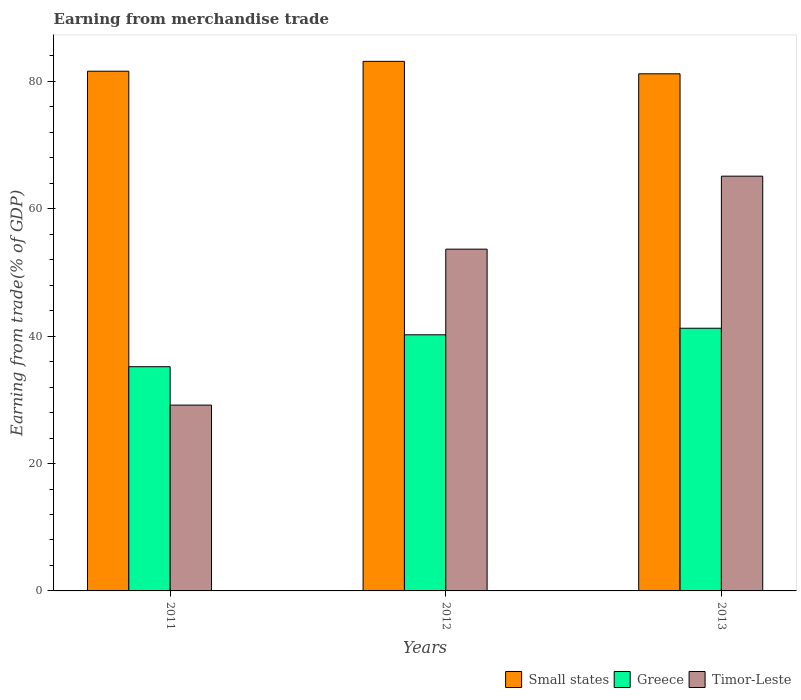How many groups of bars are there?
Offer a terse response. 3. Are the number of bars per tick equal to the number of legend labels?
Keep it short and to the point. Yes. How many bars are there on the 2nd tick from the left?
Provide a succinct answer. 3. How many bars are there on the 1st tick from the right?
Provide a succinct answer. 3. What is the label of the 1st group of bars from the left?
Keep it short and to the point. 2011. In how many cases, is the number of bars for a given year not equal to the number of legend labels?
Keep it short and to the point. 0. What is the earnings from trade in Small states in 2011?
Your response must be concise. 81.59. Across all years, what is the maximum earnings from trade in Timor-Leste?
Ensure brevity in your answer.  65.11. Across all years, what is the minimum earnings from trade in Timor-Leste?
Provide a short and direct response. 29.17. In which year was the earnings from trade in Timor-Leste maximum?
Offer a terse response. 2013. What is the total earnings from trade in Timor-Leste in the graph?
Keep it short and to the point. 147.94. What is the difference between the earnings from trade in Greece in 2012 and that in 2013?
Ensure brevity in your answer.  -1.03. What is the difference between the earnings from trade in Small states in 2011 and the earnings from trade in Greece in 2013?
Make the answer very short. 40.35. What is the average earnings from trade in Small states per year?
Make the answer very short. 81.97. In the year 2013, what is the difference between the earnings from trade in Small states and earnings from trade in Greece?
Your answer should be very brief. 39.94. What is the ratio of the earnings from trade in Greece in 2011 to that in 2012?
Provide a succinct answer. 0.88. Is the difference between the earnings from trade in Small states in 2012 and 2013 greater than the difference between the earnings from trade in Greece in 2012 and 2013?
Your answer should be compact. Yes. What is the difference between the highest and the second highest earnings from trade in Timor-Leste?
Provide a succinct answer. 11.46. What is the difference between the highest and the lowest earnings from trade in Greece?
Make the answer very short. 6.04. In how many years, is the earnings from trade in Timor-Leste greater than the average earnings from trade in Timor-Leste taken over all years?
Give a very brief answer. 2. Is the sum of the earnings from trade in Greece in 2011 and 2012 greater than the maximum earnings from trade in Small states across all years?
Your response must be concise. No. What does the 1st bar from the left in 2011 represents?
Ensure brevity in your answer.  Small states. What is the difference between two consecutive major ticks on the Y-axis?
Your answer should be very brief. 20. Are the values on the major ticks of Y-axis written in scientific E-notation?
Your answer should be compact. No. Does the graph contain any zero values?
Ensure brevity in your answer.  No. How many legend labels are there?
Offer a terse response. 3. How are the legend labels stacked?
Your answer should be very brief. Horizontal. What is the title of the graph?
Your response must be concise. Earning from merchandise trade. Does "Pacific island small states" appear as one of the legend labels in the graph?
Your response must be concise. No. What is the label or title of the X-axis?
Your response must be concise. Years. What is the label or title of the Y-axis?
Offer a terse response. Earning from trade(% of GDP). What is the Earning from trade(% of GDP) of Small states in 2011?
Provide a succinct answer. 81.59. What is the Earning from trade(% of GDP) in Greece in 2011?
Give a very brief answer. 35.2. What is the Earning from trade(% of GDP) in Timor-Leste in 2011?
Give a very brief answer. 29.17. What is the Earning from trade(% of GDP) of Small states in 2012?
Offer a very short reply. 83.14. What is the Earning from trade(% of GDP) in Greece in 2012?
Make the answer very short. 40.21. What is the Earning from trade(% of GDP) of Timor-Leste in 2012?
Offer a terse response. 53.65. What is the Earning from trade(% of GDP) of Small states in 2013?
Make the answer very short. 81.18. What is the Earning from trade(% of GDP) in Greece in 2013?
Your answer should be very brief. 41.24. What is the Earning from trade(% of GDP) in Timor-Leste in 2013?
Your response must be concise. 65.11. Across all years, what is the maximum Earning from trade(% of GDP) of Small states?
Give a very brief answer. 83.14. Across all years, what is the maximum Earning from trade(% of GDP) of Greece?
Offer a very short reply. 41.24. Across all years, what is the maximum Earning from trade(% of GDP) of Timor-Leste?
Offer a terse response. 65.11. Across all years, what is the minimum Earning from trade(% of GDP) in Small states?
Make the answer very short. 81.18. Across all years, what is the minimum Earning from trade(% of GDP) in Greece?
Offer a terse response. 35.2. Across all years, what is the minimum Earning from trade(% of GDP) of Timor-Leste?
Provide a short and direct response. 29.17. What is the total Earning from trade(% of GDP) of Small states in the graph?
Give a very brief answer. 245.91. What is the total Earning from trade(% of GDP) in Greece in the graph?
Your answer should be compact. 116.64. What is the total Earning from trade(% of GDP) of Timor-Leste in the graph?
Offer a terse response. 147.94. What is the difference between the Earning from trade(% of GDP) of Small states in 2011 and that in 2012?
Your answer should be very brief. -1.55. What is the difference between the Earning from trade(% of GDP) of Greece in 2011 and that in 2012?
Make the answer very short. -5.01. What is the difference between the Earning from trade(% of GDP) of Timor-Leste in 2011 and that in 2012?
Your answer should be compact. -24.48. What is the difference between the Earning from trade(% of GDP) of Small states in 2011 and that in 2013?
Make the answer very short. 0.41. What is the difference between the Earning from trade(% of GDP) in Greece in 2011 and that in 2013?
Ensure brevity in your answer.  -6.04. What is the difference between the Earning from trade(% of GDP) in Timor-Leste in 2011 and that in 2013?
Give a very brief answer. -35.94. What is the difference between the Earning from trade(% of GDP) of Small states in 2012 and that in 2013?
Provide a short and direct response. 1.95. What is the difference between the Earning from trade(% of GDP) in Greece in 2012 and that in 2013?
Your answer should be very brief. -1.03. What is the difference between the Earning from trade(% of GDP) in Timor-Leste in 2012 and that in 2013?
Your response must be concise. -11.46. What is the difference between the Earning from trade(% of GDP) of Small states in 2011 and the Earning from trade(% of GDP) of Greece in 2012?
Provide a succinct answer. 41.38. What is the difference between the Earning from trade(% of GDP) of Small states in 2011 and the Earning from trade(% of GDP) of Timor-Leste in 2012?
Provide a short and direct response. 27.94. What is the difference between the Earning from trade(% of GDP) of Greece in 2011 and the Earning from trade(% of GDP) of Timor-Leste in 2012?
Keep it short and to the point. -18.45. What is the difference between the Earning from trade(% of GDP) of Small states in 2011 and the Earning from trade(% of GDP) of Greece in 2013?
Your response must be concise. 40.35. What is the difference between the Earning from trade(% of GDP) of Small states in 2011 and the Earning from trade(% of GDP) of Timor-Leste in 2013?
Your response must be concise. 16.48. What is the difference between the Earning from trade(% of GDP) in Greece in 2011 and the Earning from trade(% of GDP) in Timor-Leste in 2013?
Offer a terse response. -29.91. What is the difference between the Earning from trade(% of GDP) of Small states in 2012 and the Earning from trade(% of GDP) of Greece in 2013?
Make the answer very short. 41.9. What is the difference between the Earning from trade(% of GDP) of Small states in 2012 and the Earning from trade(% of GDP) of Timor-Leste in 2013?
Your answer should be compact. 18.02. What is the difference between the Earning from trade(% of GDP) in Greece in 2012 and the Earning from trade(% of GDP) in Timor-Leste in 2013?
Offer a very short reply. -24.9. What is the average Earning from trade(% of GDP) in Small states per year?
Ensure brevity in your answer.  81.97. What is the average Earning from trade(% of GDP) of Greece per year?
Keep it short and to the point. 38.88. What is the average Earning from trade(% of GDP) in Timor-Leste per year?
Provide a short and direct response. 49.31. In the year 2011, what is the difference between the Earning from trade(% of GDP) of Small states and Earning from trade(% of GDP) of Greece?
Your response must be concise. 46.39. In the year 2011, what is the difference between the Earning from trade(% of GDP) of Small states and Earning from trade(% of GDP) of Timor-Leste?
Your response must be concise. 52.42. In the year 2011, what is the difference between the Earning from trade(% of GDP) in Greece and Earning from trade(% of GDP) in Timor-Leste?
Your answer should be very brief. 6.03. In the year 2012, what is the difference between the Earning from trade(% of GDP) in Small states and Earning from trade(% of GDP) in Greece?
Offer a very short reply. 42.93. In the year 2012, what is the difference between the Earning from trade(% of GDP) in Small states and Earning from trade(% of GDP) in Timor-Leste?
Provide a succinct answer. 29.48. In the year 2012, what is the difference between the Earning from trade(% of GDP) of Greece and Earning from trade(% of GDP) of Timor-Leste?
Your answer should be compact. -13.44. In the year 2013, what is the difference between the Earning from trade(% of GDP) in Small states and Earning from trade(% of GDP) in Greece?
Provide a succinct answer. 39.94. In the year 2013, what is the difference between the Earning from trade(% of GDP) in Small states and Earning from trade(% of GDP) in Timor-Leste?
Offer a very short reply. 16.07. In the year 2013, what is the difference between the Earning from trade(% of GDP) of Greece and Earning from trade(% of GDP) of Timor-Leste?
Your response must be concise. -23.88. What is the ratio of the Earning from trade(% of GDP) in Small states in 2011 to that in 2012?
Your response must be concise. 0.98. What is the ratio of the Earning from trade(% of GDP) of Greece in 2011 to that in 2012?
Your answer should be very brief. 0.88. What is the ratio of the Earning from trade(% of GDP) of Timor-Leste in 2011 to that in 2012?
Give a very brief answer. 0.54. What is the ratio of the Earning from trade(% of GDP) in Small states in 2011 to that in 2013?
Ensure brevity in your answer.  1. What is the ratio of the Earning from trade(% of GDP) of Greece in 2011 to that in 2013?
Your answer should be very brief. 0.85. What is the ratio of the Earning from trade(% of GDP) in Timor-Leste in 2011 to that in 2013?
Offer a terse response. 0.45. What is the ratio of the Earning from trade(% of GDP) of Small states in 2012 to that in 2013?
Make the answer very short. 1.02. What is the ratio of the Earning from trade(% of GDP) of Greece in 2012 to that in 2013?
Give a very brief answer. 0.98. What is the ratio of the Earning from trade(% of GDP) in Timor-Leste in 2012 to that in 2013?
Ensure brevity in your answer.  0.82. What is the difference between the highest and the second highest Earning from trade(% of GDP) of Small states?
Provide a succinct answer. 1.55. What is the difference between the highest and the second highest Earning from trade(% of GDP) in Greece?
Your answer should be very brief. 1.03. What is the difference between the highest and the second highest Earning from trade(% of GDP) of Timor-Leste?
Give a very brief answer. 11.46. What is the difference between the highest and the lowest Earning from trade(% of GDP) in Small states?
Your answer should be compact. 1.95. What is the difference between the highest and the lowest Earning from trade(% of GDP) of Greece?
Ensure brevity in your answer.  6.04. What is the difference between the highest and the lowest Earning from trade(% of GDP) in Timor-Leste?
Your answer should be very brief. 35.94. 